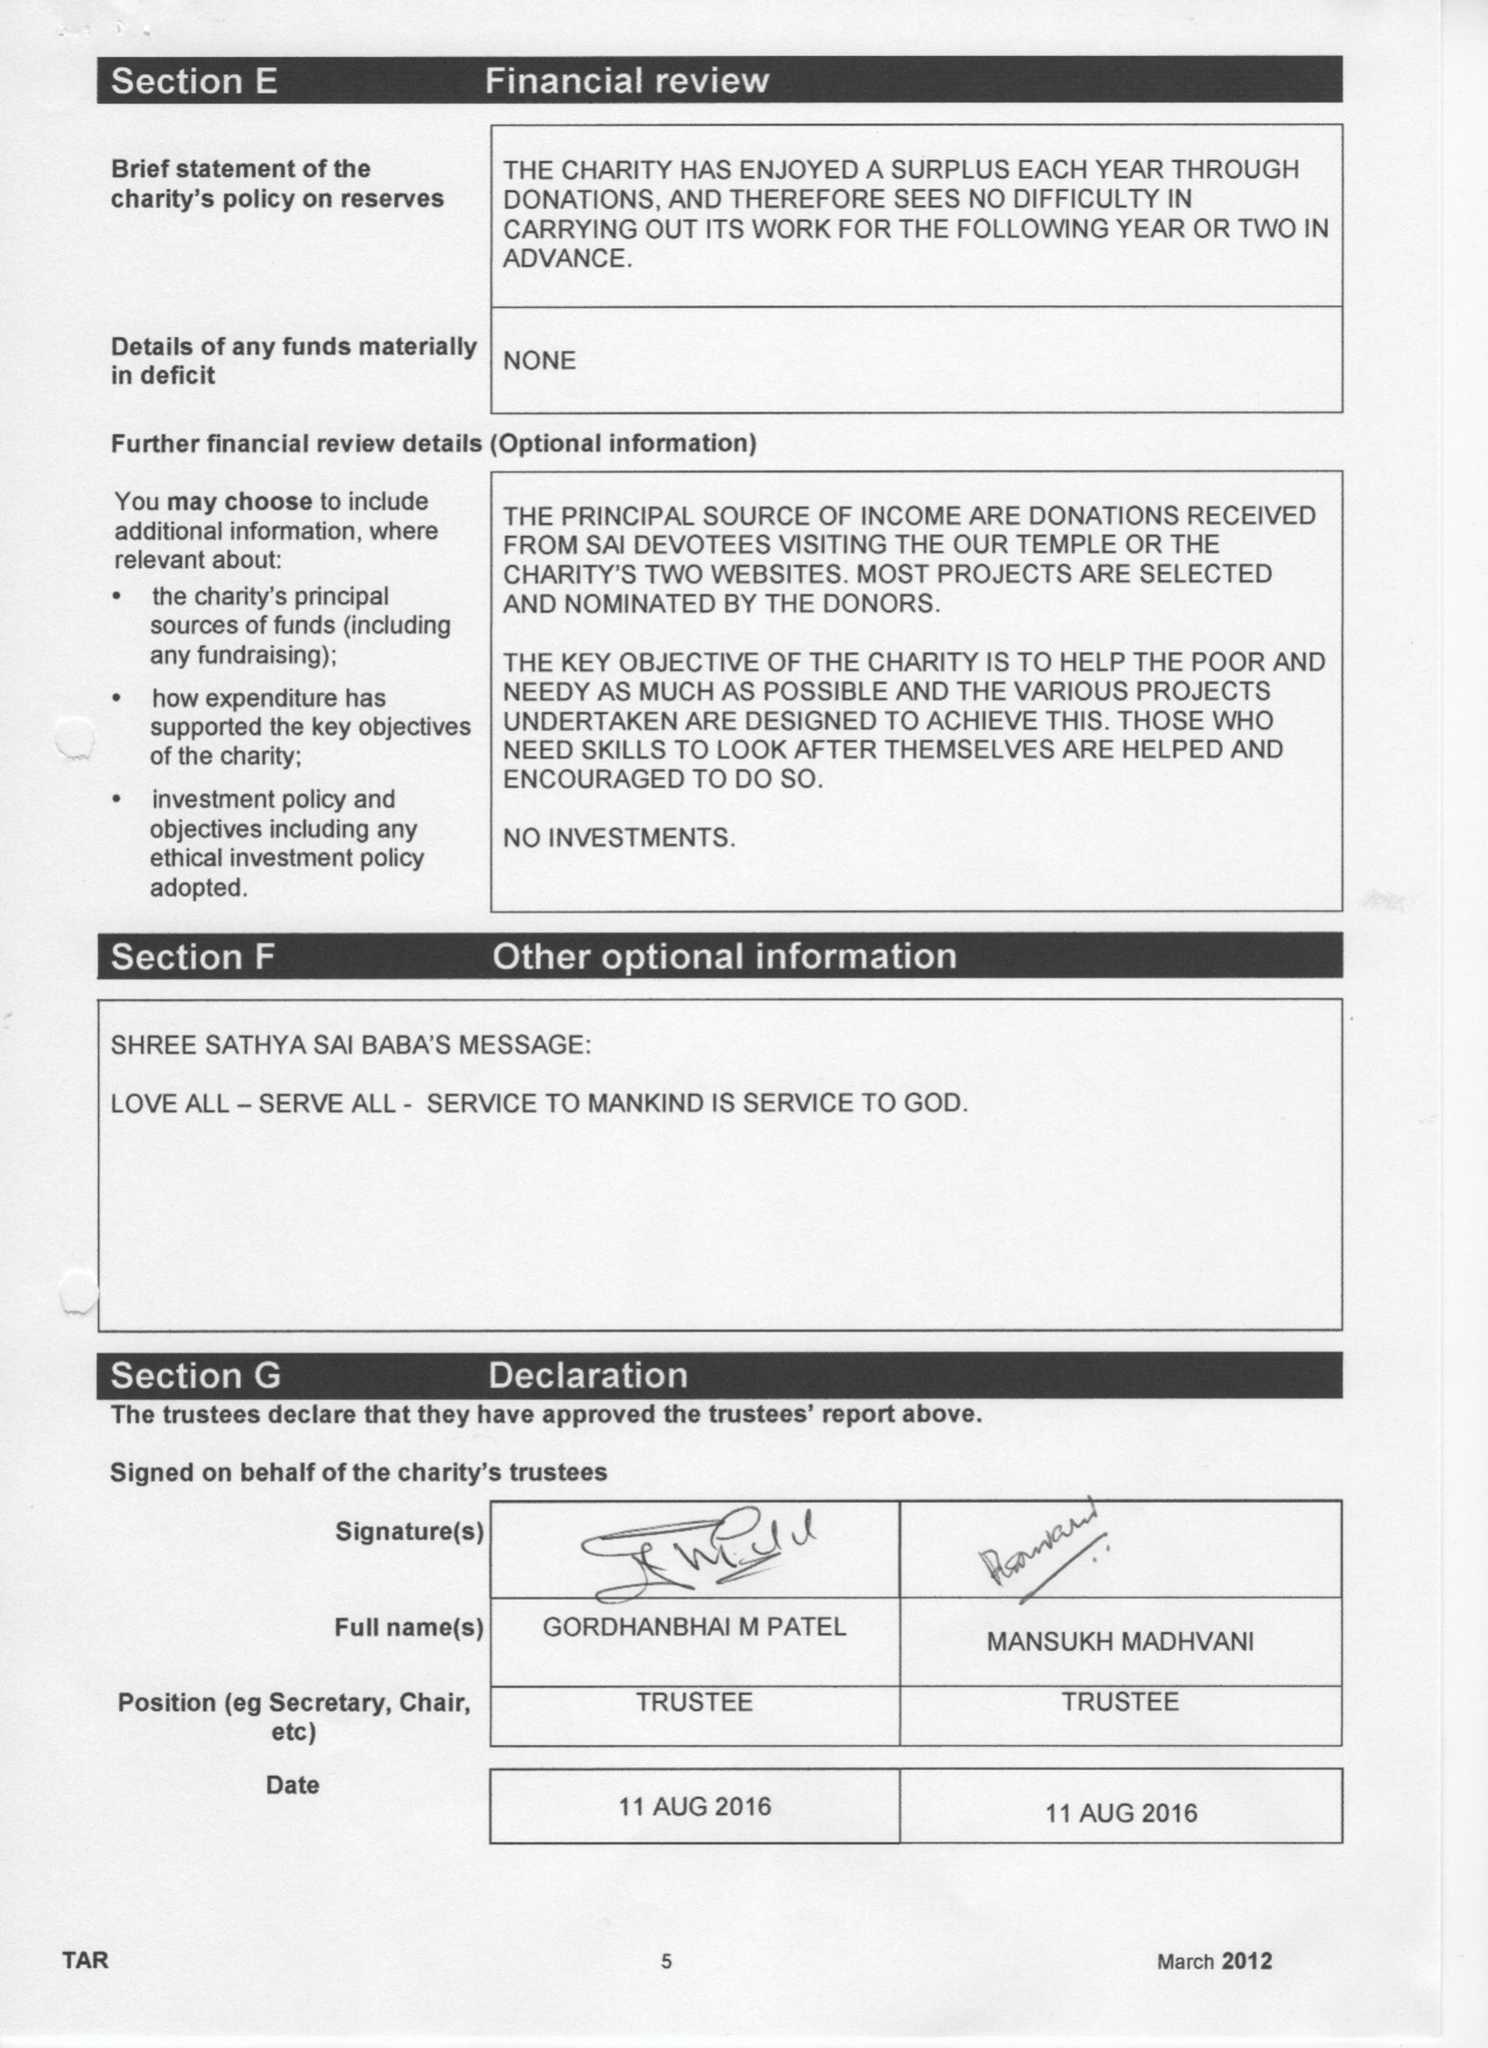What is the value for the address__post_town?
Answer the question using a single word or phrase. HARROW 